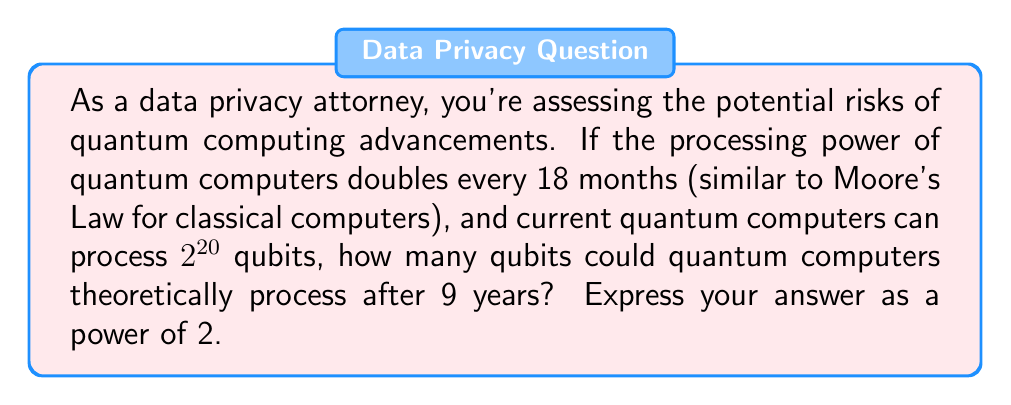Help me with this question. Let's approach this step-by-step:

1) First, let's calculate how many 18-month periods are in 9 years:
   $$ \frac{9 \text{ years}}{1.5 \text{ years}} = 6 \text{ periods} $$

2) Now, we know that the processing power doubles every period. This means we're dealing with exponential growth. The formula for exponential growth is:

   $$ A = A_0 \cdot 2^n $$

   Where:
   $A$ is the final amount
   $A_0$ is the initial amount
   $n$ is the number of periods

3) In this case:
   $A_0 = 2^{20}$ (initial processing power)
   $n = 6$ (number of 18-month periods in 9 years)

4) Let's substitute these into our formula:

   $$ A = 2^{20} \cdot 2^6 $$

5) Using the laws of exponents, we can simplify this:

   $$ A = 2^{20+6} = 2^{26} $$

Therefore, after 9 years, quantum computers could theoretically process $2^{26}$ qubits.
Answer: $2^{26}$ qubits 